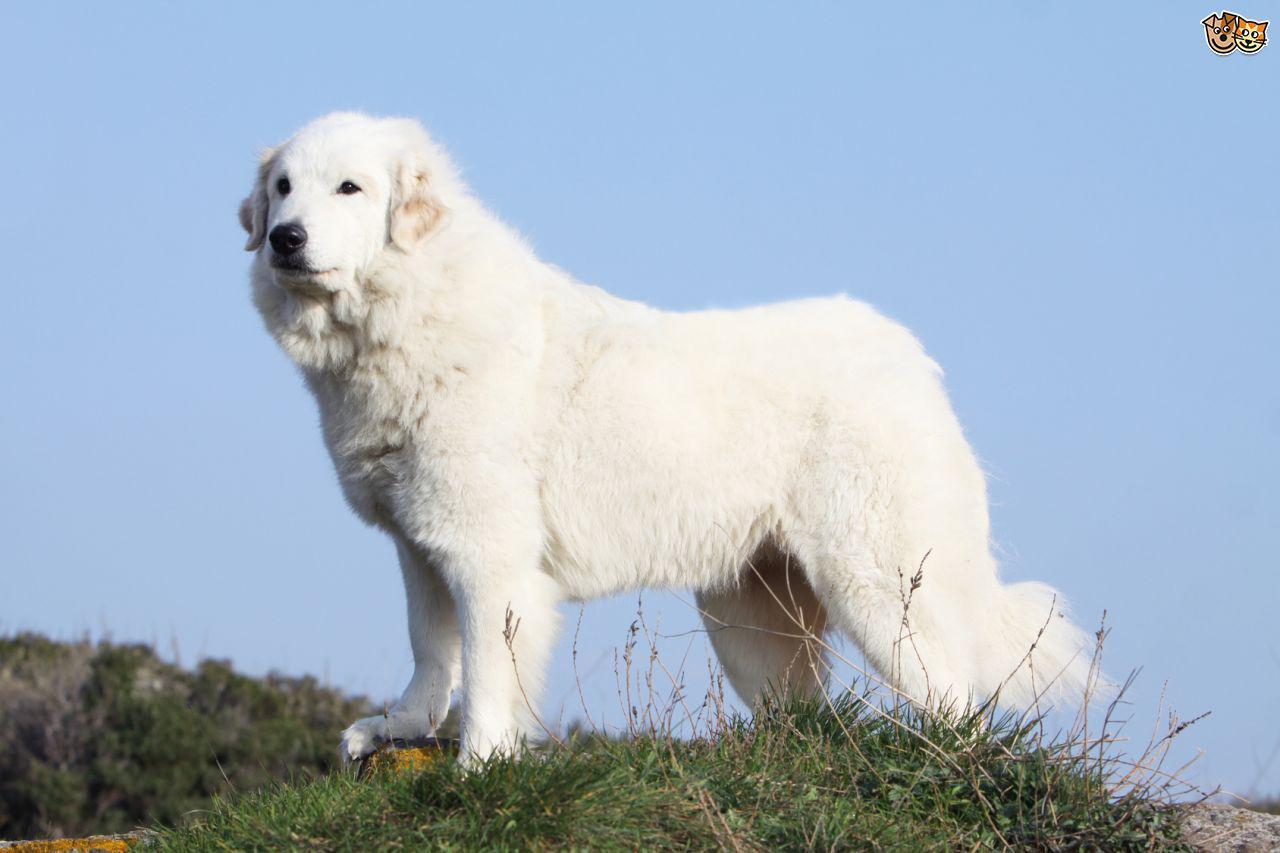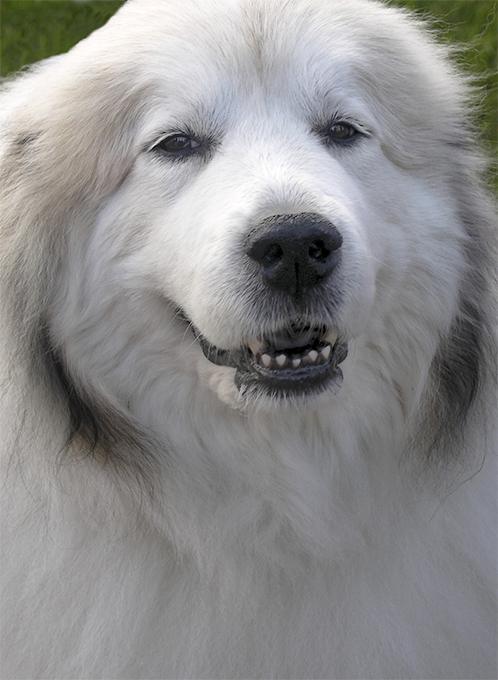The first image is the image on the left, the second image is the image on the right. For the images displayed, is the sentence "At least one of the dogs has its tongue sticking out." factually correct? Answer yes or no. No. The first image is the image on the left, the second image is the image on the right. Assess this claim about the two images: "Left image shows a dog standing in profile with body turned leftward.". Correct or not? Answer yes or no. Yes. 